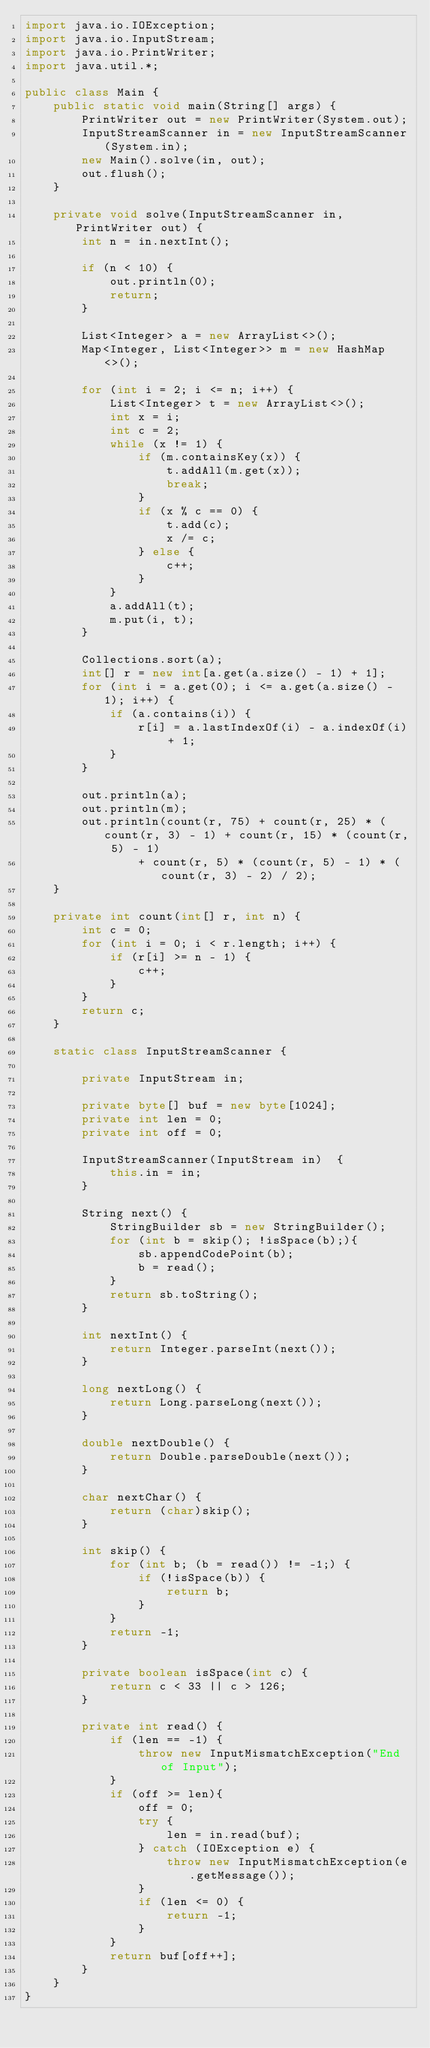Convert code to text. <code><loc_0><loc_0><loc_500><loc_500><_Java_>import java.io.IOException;
import java.io.InputStream;
import java.io.PrintWriter;
import java.util.*;

public class Main {
    public static void main(String[] args) {
        PrintWriter out = new PrintWriter(System.out);
        InputStreamScanner in = new InputStreamScanner(System.in);
        new Main().solve(in, out);
        out.flush();
    }

    private void solve(InputStreamScanner in, PrintWriter out) {
        int n = in.nextInt();

        if (n < 10) {
            out.println(0);
            return;
        }

        List<Integer> a = new ArrayList<>();
        Map<Integer, List<Integer>> m = new HashMap<>();

        for (int i = 2; i <= n; i++) {
            List<Integer> t = new ArrayList<>();
            int x = i;
            int c = 2;
            while (x != 1) {
                if (m.containsKey(x)) {
                    t.addAll(m.get(x));
                    break;
                }
                if (x % c == 0) {
                    t.add(c);
                    x /= c;
                } else {
                    c++;
                }
            }
            a.addAll(t);
            m.put(i, t);
        }

        Collections.sort(a);
        int[] r = new int[a.get(a.size() - 1) + 1];
        for (int i = a.get(0); i <= a.get(a.size() - 1); i++) {
            if (a.contains(i)) {
                r[i] = a.lastIndexOf(i) - a.indexOf(i) + 1;
            }
        }

        out.println(a);
        out.println(m);
        out.println(count(r, 75) + count(r, 25) * (count(r, 3) - 1) + count(r, 15) * (count(r, 5) - 1)
                + count(r, 5) * (count(r, 5) - 1) * (count(r, 3) - 2) / 2);
    }

    private int count(int[] r, int n) {
        int c = 0;
        for (int i = 0; i < r.length; i++) {
            if (r[i] >= n - 1) {
                c++;
            }
        }
        return c;
    }

    static class InputStreamScanner {

        private InputStream in;

        private byte[] buf = new byte[1024];
        private int len = 0;
        private int off = 0;

        InputStreamScanner(InputStream in)	{
            this.in = in;
        }

        String next() {
            StringBuilder sb = new StringBuilder();
            for (int b = skip(); !isSpace(b);){
                sb.appendCodePoint(b);
                b = read();
            }
            return sb.toString();
        }

        int nextInt() {
            return Integer.parseInt(next());
        }

        long nextLong() {
            return Long.parseLong(next());
        }

        double nextDouble() {
            return Double.parseDouble(next());
        }

        char nextChar() {
            return (char)skip();
        }

        int skip() {
            for (int b; (b = read()) != -1;) {
                if (!isSpace(b)) {
                    return b;
                }
            }
            return -1;
        }

        private boolean isSpace(int c) {
            return c < 33 || c > 126;
        }

        private int read() {
            if (len == -1) {
                throw new InputMismatchException("End of Input");
            }
            if (off >= len){
                off = 0;
                try {
                    len = in.read(buf);
                } catch (IOException e) {
                    throw new InputMismatchException(e.getMessage());
                }
                if (len <= 0) {
                    return -1;
                }
            }
            return buf[off++];
        }
    }
}
</code> 